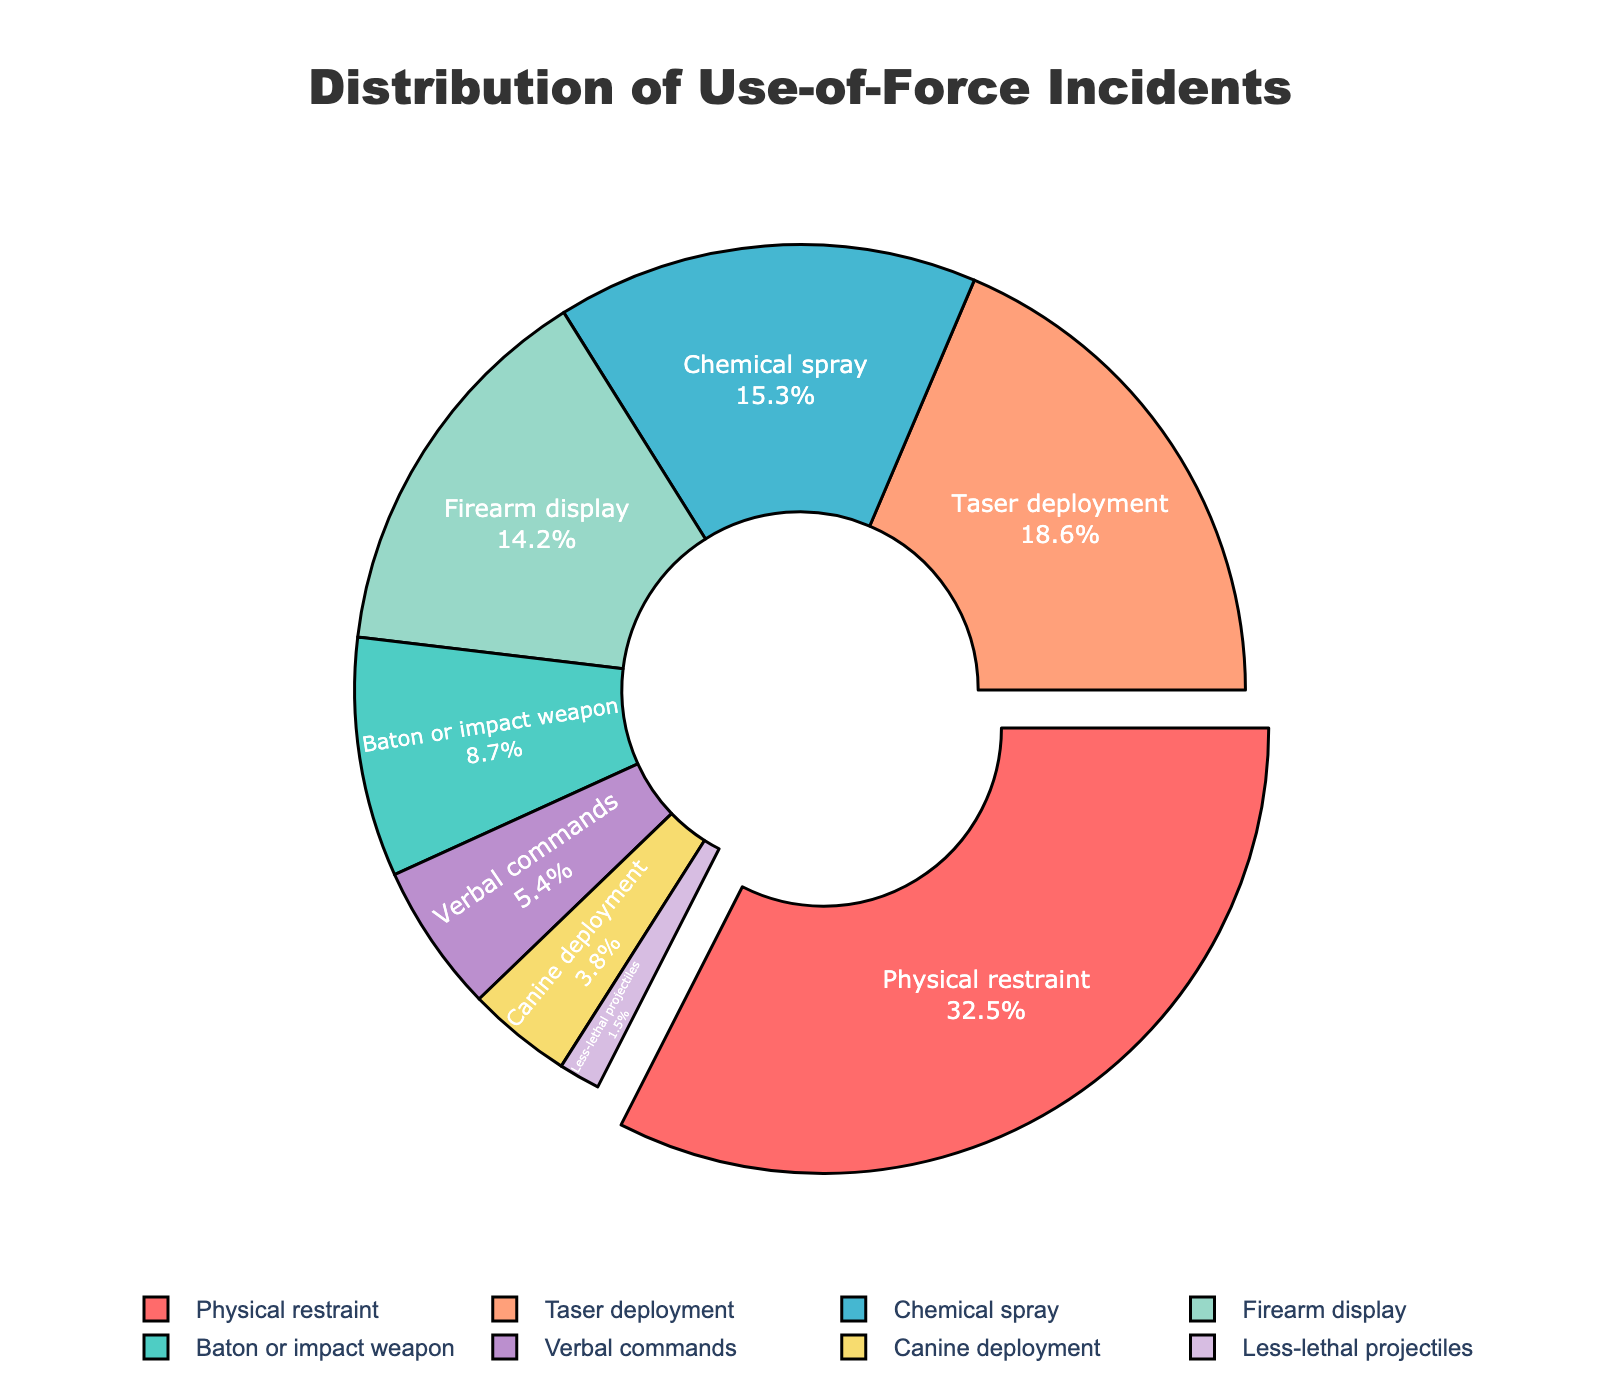Which type of force has the highest percentage? By examining the pie chart, we can identify that the segment with the highest percentage is the largest segment. In this case, it is "Physical restraint."
Answer: Physical restraint What is the combined percentage of Taser deployment and Firearm display? To find the combined percentage, add the percentage values for Taser deployment (18.6%) and Firearm display (14.2%). 18.6 + 14.2 = 32.8%
Answer: 32.8% Which type of force has the lowest percentage? By looking at the pie chart, the segment with the smallest proportion represents the type of force with the lowest percentage. Here, it is "Less-lethal projectiles."
Answer: Less-lethal projectiles Is the percentage of Chemical spray greater than the percentage of Verbal commands? Compare the two percentage values directly from the chart: Chemical spray (15.3%) and Verbal commands (5.4%). Since 15.3 > 5.4, the answer is yes.
Answer: Yes What is the difference in percentage between Baton or impact weapon and Canine deployment? Subtract the percentage value of Canine deployment (3.8%) from that of Baton or impact weapon (8.7%). 8.7 - 3.8 = 4.9%.
Answer: 4.9% Are Physical restraint and Taser deployment together responsible for over half of the incidents? Calculate the combined percentage of Physical restraint (32.5%) and Taser deployment (18.6%). 32.5 + 18.6 = 51.1%. Since 51.1% is more than half, the answer is yes.
Answer: Yes Which type of force is represented by the yellowish segment in the pie chart? By referring to the color legend in the pie chart, we can identify that the yellowish segment represents Firearm display.
Answer: Firearm display How many types of use-of-force incidents account for less than 10% each? Identify and count the segments with percentages less than 10%. These are Baton or impact weapon (8.7%), Canine deployment (3.8%), Verbal commands (5.4%), and Less-lethal projectiles (1.5%). There are 4 such types.
Answer: 4 What is the total percentage of incidents involving Canine deployment, Less-lethal projectiles, and Verbal commands? Sum the percentages of Canine deployment (3.8%), Less-lethal projectiles (1.5%), and Verbal commands (5.4%). 3.8 + 1.5 + 5.4 = 10.7%.
Answer: 10.7% Is the sum of the percentages of Baton or impact weapon and Chemical spray equal to the percentage of Physical restraint? Add the percentages of Baton or impact weapon (8.7%) and Chemical spray (15.3%). 8.7 + 15.3 = 24%. Since 24% is not equal to 32.5%, the answer is no.
Answer: No 